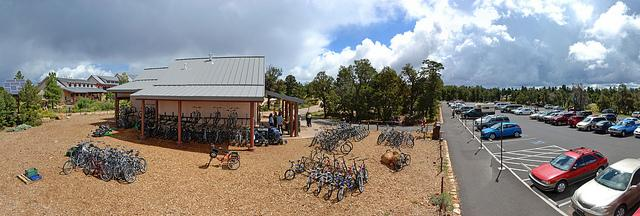What kind of facility can be found nearby?

Choices:
A) fish pond
B) bike trail
C) hiking trail
D) picnic area bike trail 